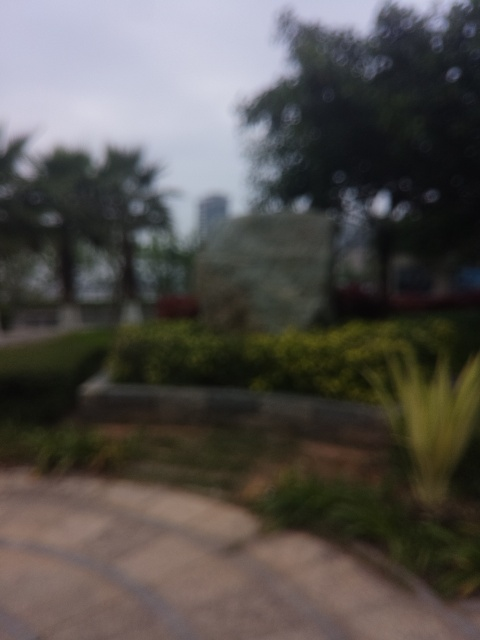Are the details of the stone carving clear?
A. No
B. Yes
Answer with the option's letter from the given choices directly.
 A. 